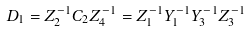Convert formula to latex. <formula><loc_0><loc_0><loc_500><loc_500>D _ { 1 } = Z _ { 2 } ^ { - 1 } C _ { 2 } Z _ { 4 } ^ { - 1 } = Z _ { 1 } ^ { - 1 } Y _ { 1 } ^ { - 1 } Y _ { 3 } ^ { - 1 } Z _ { 3 } ^ { - 1 }</formula> 